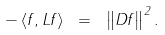<formula> <loc_0><loc_0><loc_500><loc_500>- \left \langle f , L f \right \rangle \ = \ \left \| D f \right \| ^ { 2 } .</formula> 